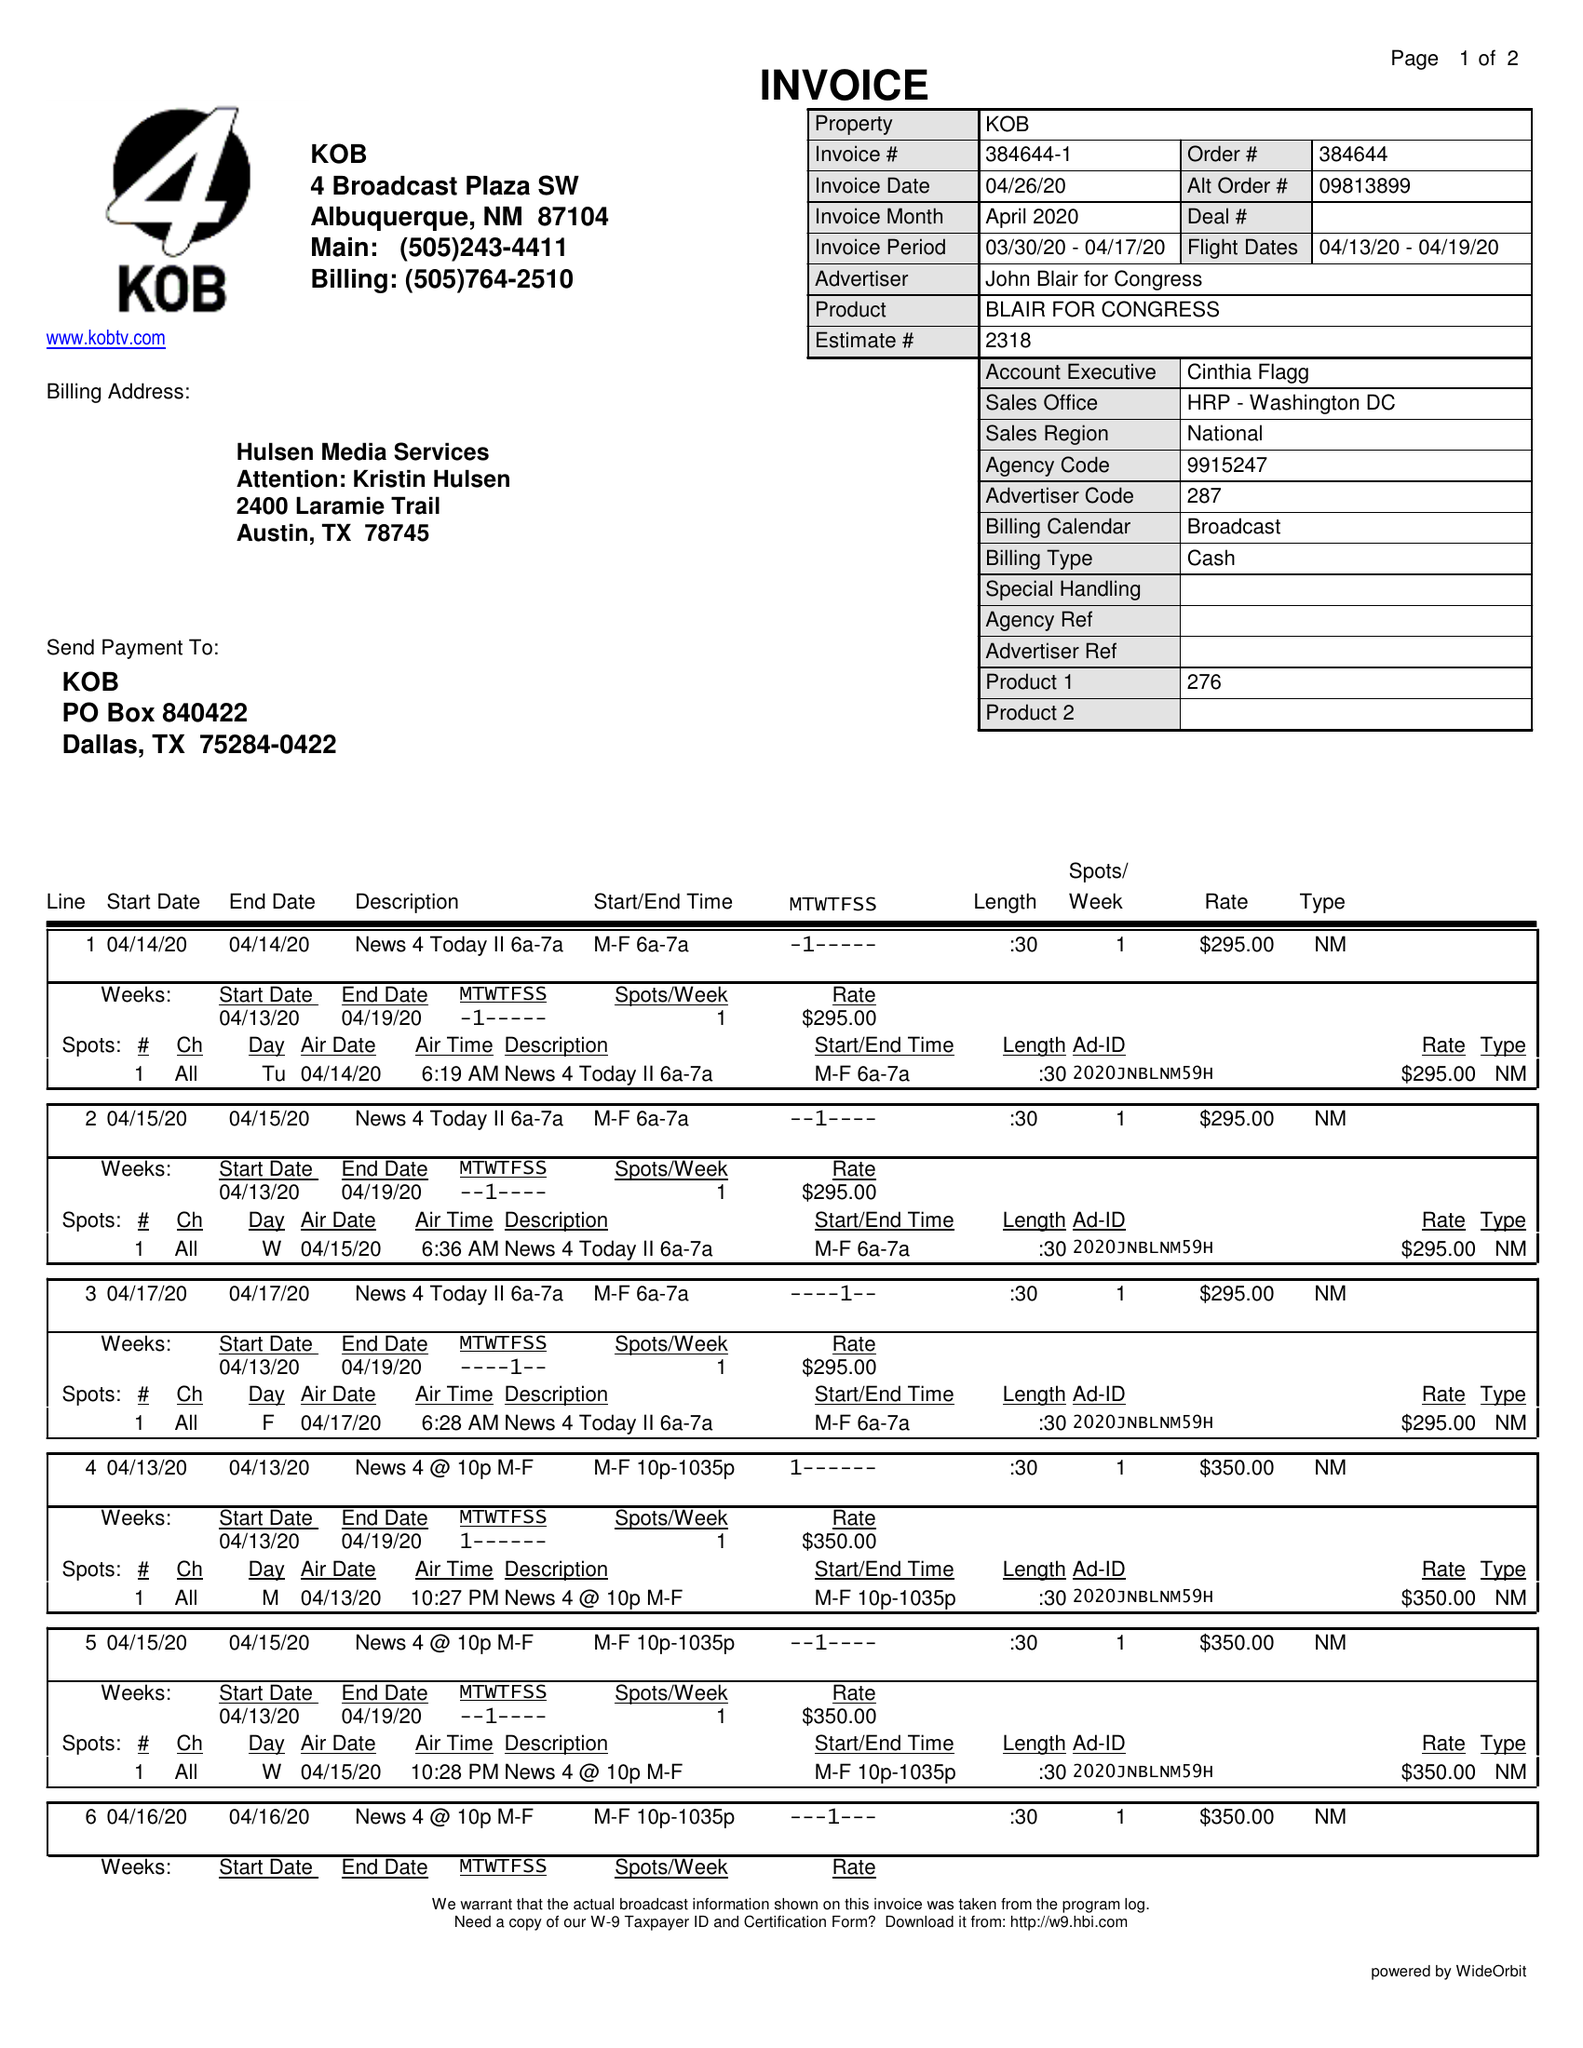What is the value for the flight_from?
Answer the question using a single word or phrase. 04/13/20 